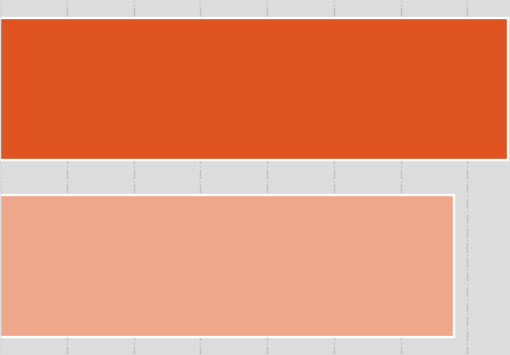Convert chart. <chart><loc_0><loc_0><loc_500><loc_500><bar_chart><fcel>FirstEnergy<fcel>FES<nl><fcel>19<fcel>17<nl></chart> 